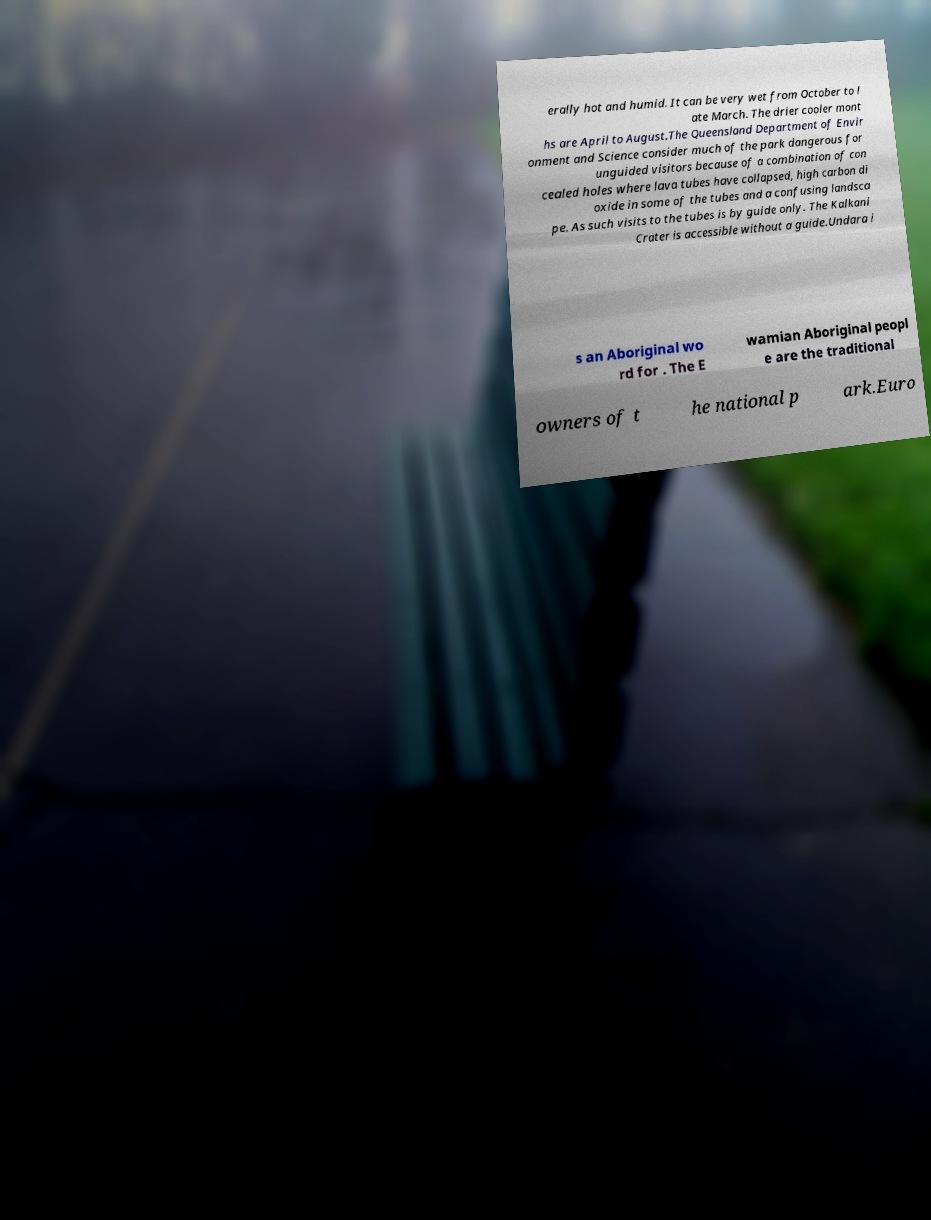Can you accurately transcribe the text from the provided image for me? erally hot and humid. It can be very wet from October to l ate March. The drier cooler mont hs are April to August.The Queensland Department of Envir onment and Science consider much of the park dangerous for unguided visitors because of a combination of con cealed holes where lava tubes have collapsed, high carbon di oxide in some of the tubes and a confusing landsca pe. As such visits to the tubes is by guide only. The Kalkani Crater is accessible without a guide.Undara i s an Aboriginal wo rd for . The E wamian Aboriginal peopl e are the traditional owners of t he national p ark.Euro 